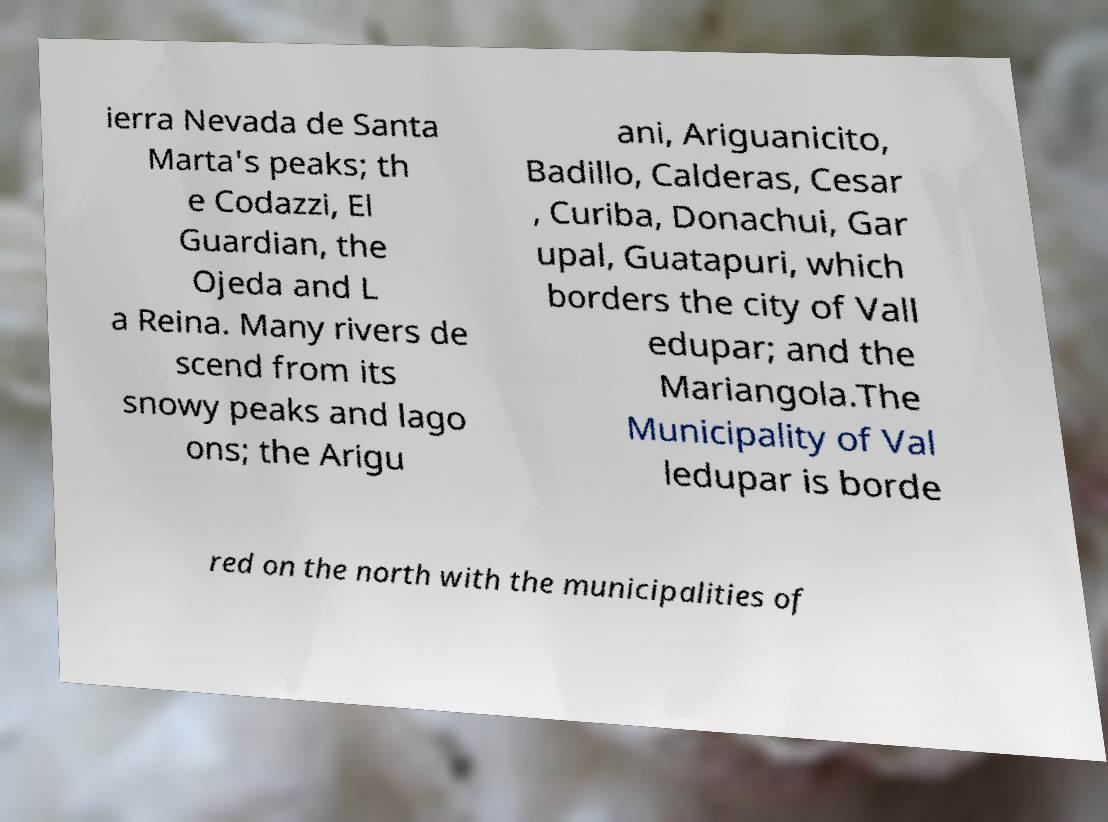Could you extract and type out the text from this image? ierra Nevada de Santa Marta's peaks; th e Codazzi, El Guardian, the Ojeda and L a Reina. Many rivers de scend from its snowy peaks and lago ons; the Arigu ani, Ariguanicito, Badillo, Calderas, Cesar , Curiba, Donachui, Gar upal, Guatapuri, which borders the city of Vall edupar; and the Mariangola.The Municipality of Val ledupar is borde red on the north with the municipalities of 